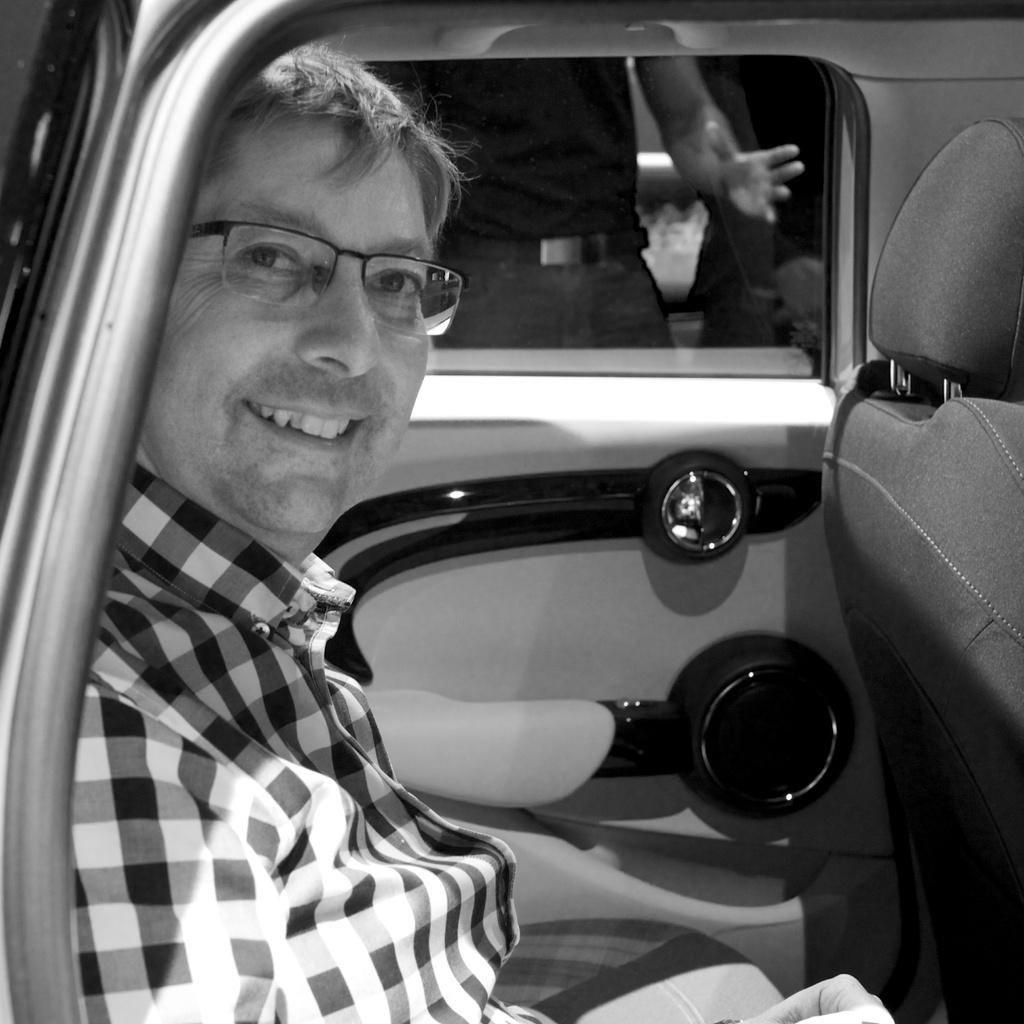Who is present in the image? There is a man and another person in the image. What is the man wearing in the image? The man is wearing spectacles in the image. What is the man's facial expression in the image? The man is smiling in the image. What is the man doing in the image? The man is sitting on a vehicle in the image. What is the other person doing in the image? The other person is standing at the window of the vehicle in the image. What type of beetle can be seen crawling on the man's spectacles in the image? There is no beetle present on the man's spectacles in the image. What advice would the queen give to the man in the image? There is no queen present in the image, so it is not possible to determine what advice she might give. 